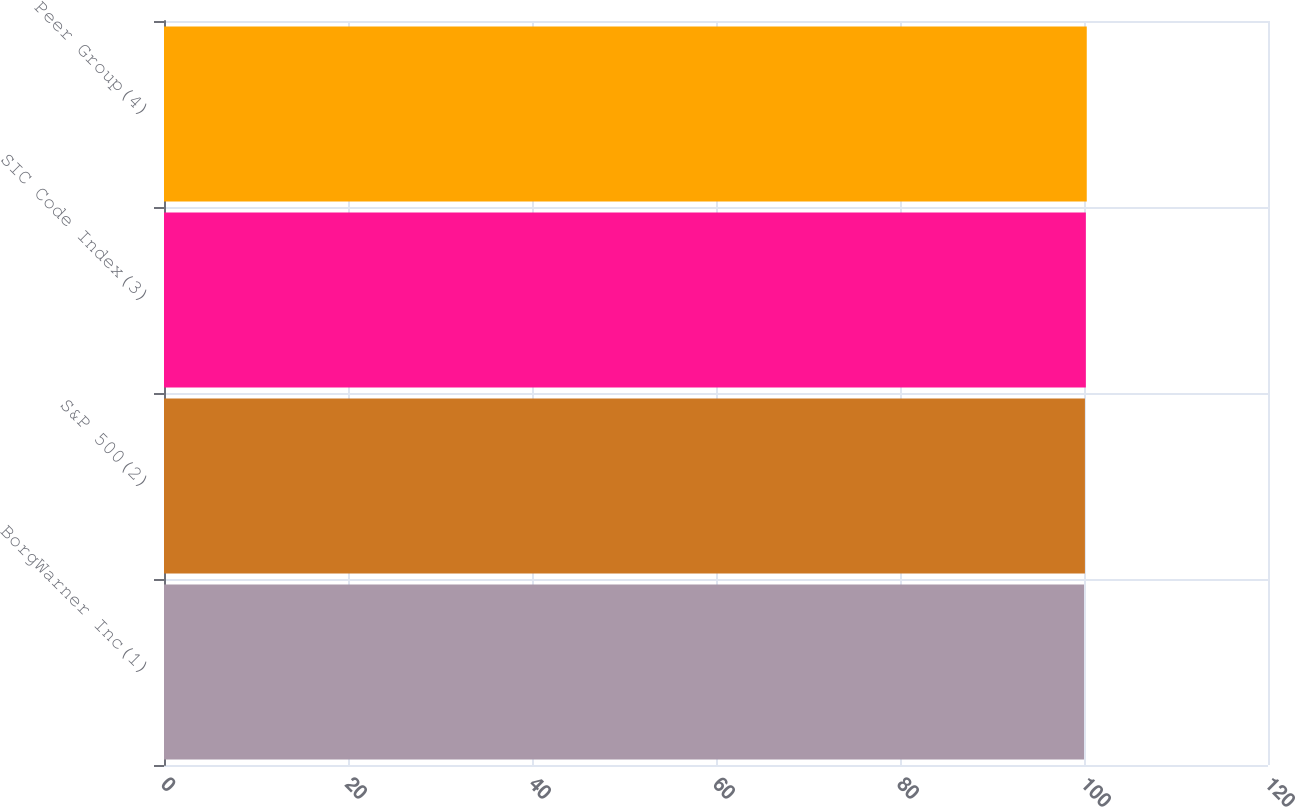Convert chart to OTSL. <chart><loc_0><loc_0><loc_500><loc_500><bar_chart><fcel>BorgWarner Inc(1)<fcel>S&P 500(2)<fcel>SIC Code Index(3)<fcel>Peer Group(4)<nl><fcel>100<fcel>100.1<fcel>100.2<fcel>100.3<nl></chart> 